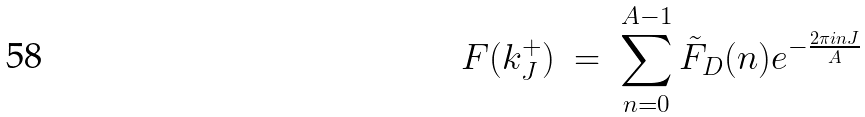<formula> <loc_0><loc_0><loc_500><loc_500>F ( k _ { J } ^ { + } ) \ = \ \sum _ { n = 0 } ^ { A - 1 } \tilde { F } _ { D } ( n ) e ^ { - \frac { 2 \pi i n J } { A } }</formula> 